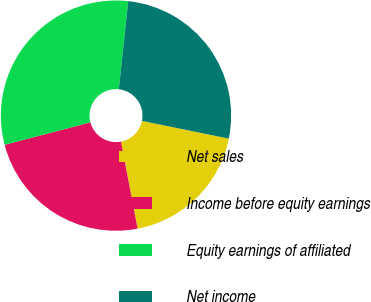<chart> <loc_0><loc_0><loc_500><loc_500><pie_chart><fcel>Net sales<fcel>Income before equity earnings<fcel>Equity earnings of affiliated<fcel>Net income<nl><fcel>18.8%<fcel>23.93%<fcel>30.77%<fcel>26.5%<nl></chart> 